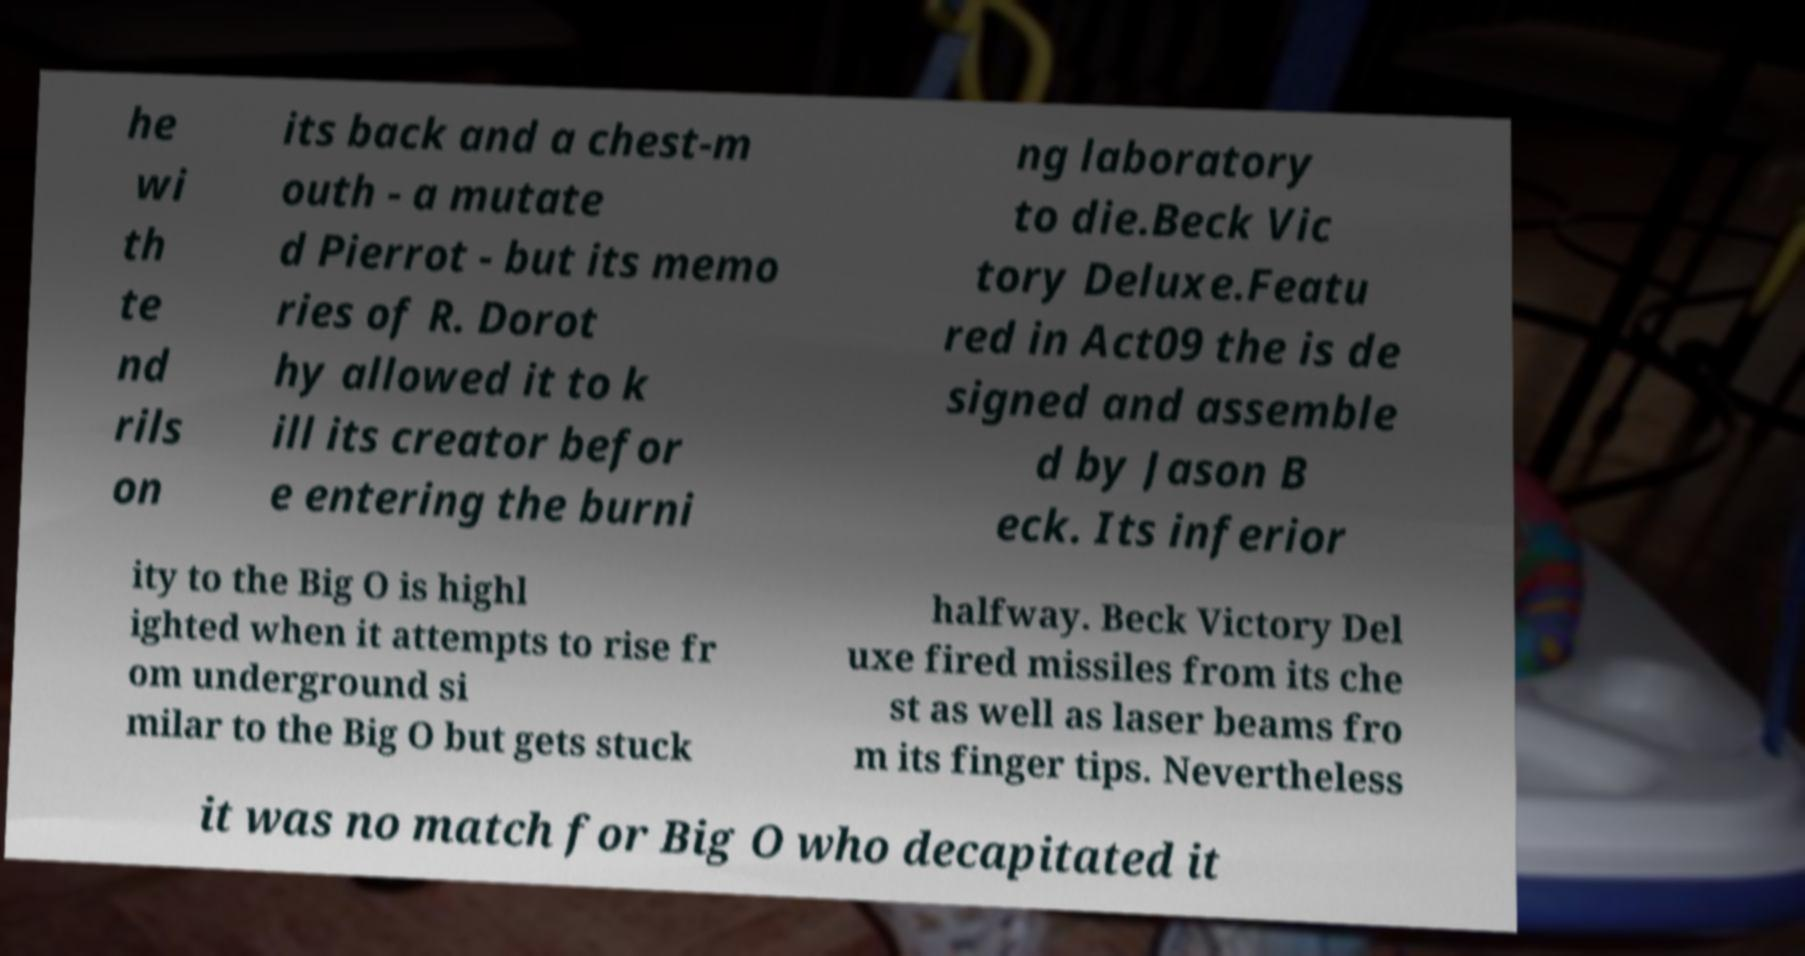Could you extract and type out the text from this image? he wi th te nd rils on its back and a chest-m outh - a mutate d Pierrot - but its memo ries of R. Dorot hy allowed it to k ill its creator befor e entering the burni ng laboratory to die.Beck Vic tory Deluxe.Featu red in Act09 the is de signed and assemble d by Jason B eck. Its inferior ity to the Big O is highl ighted when it attempts to rise fr om underground si milar to the Big O but gets stuck halfway. Beck Victory Del uxe fired missiles from its che st as well as laser beams fro m its finger tips. Nevertheless it was no match for Big O who decapitated it 